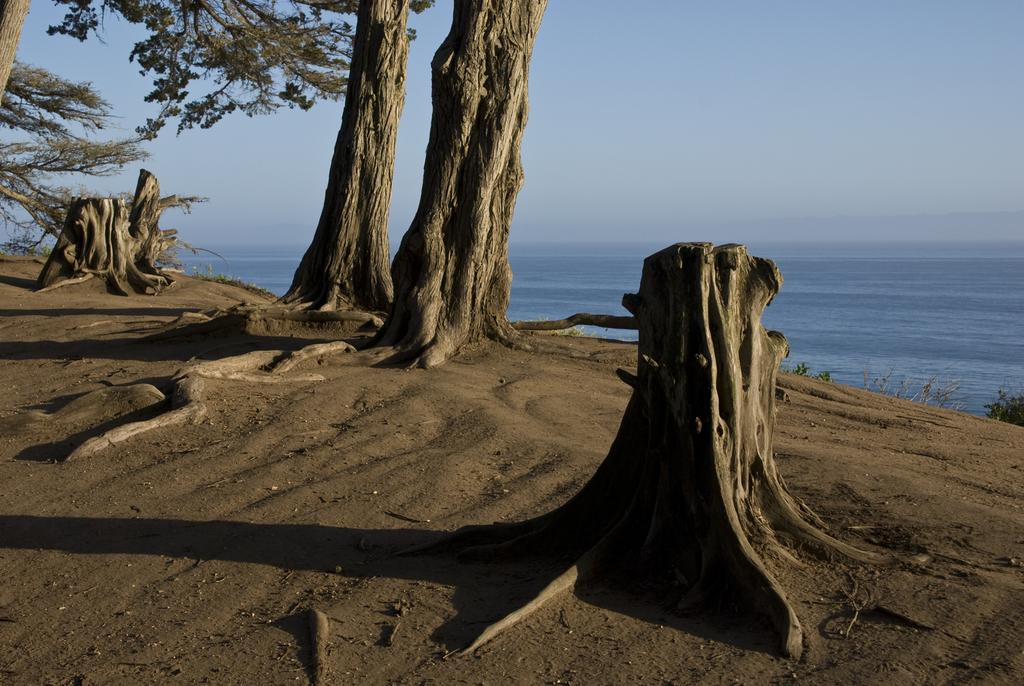What type of natural elements are present in the image? There is a group of trees and tree stumps in the image. What can be seen in the background of the image? Water and the sky are visible in the background of the image. How many types of vegetation can be seen in the image? There are two types of vegetation: a group of trees and tree stumps. What type of paint is being used to decorate the cakes in the image? There are no cakes or paint present in the image; it features a group of trees, tree stumps, water, and the sky. 